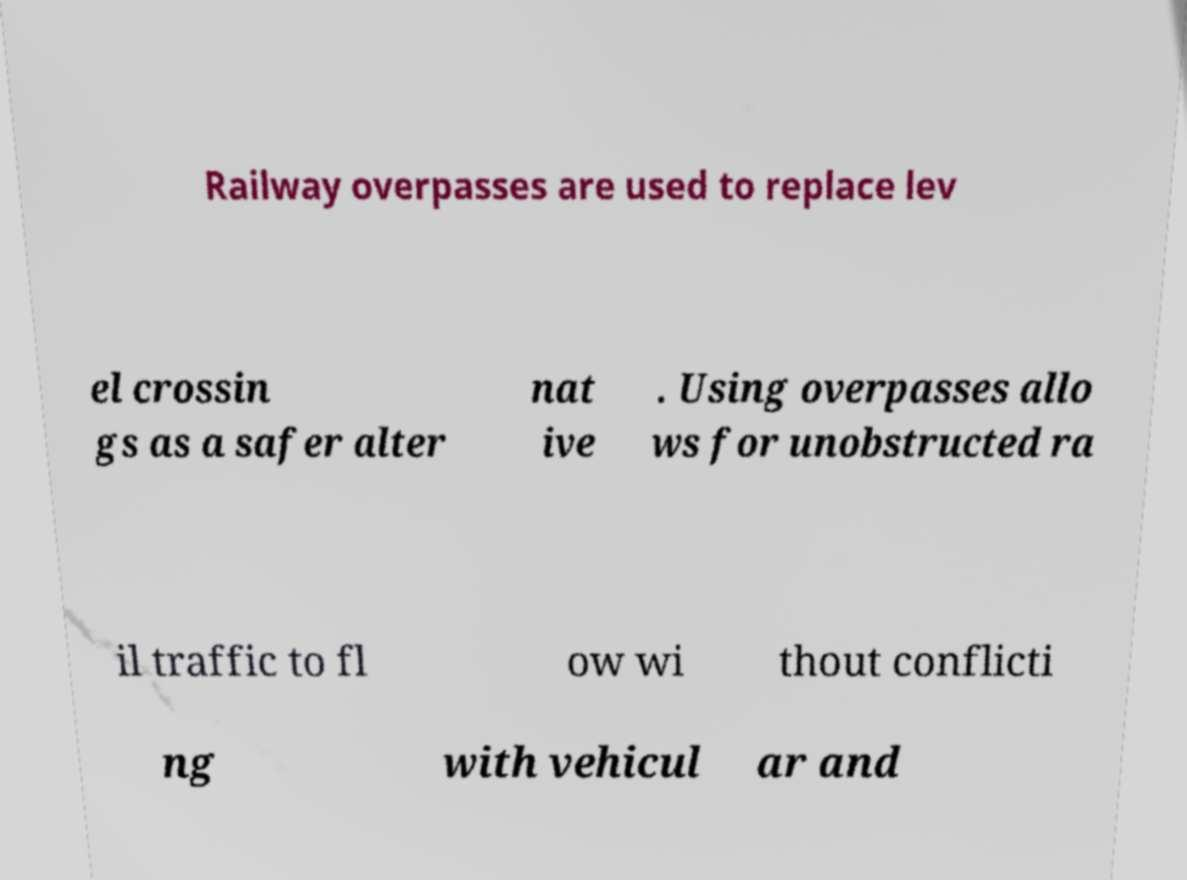For documentation purposes, I need the text within this image transcribed. Could you provide that? Railway overpasses are used to replace lev el crossin gs as a safer alter nat ive . Using overpasses allo ws for unobstructed ra il traffic to fl ow wi thout conflicti ng with vehicul ar and 